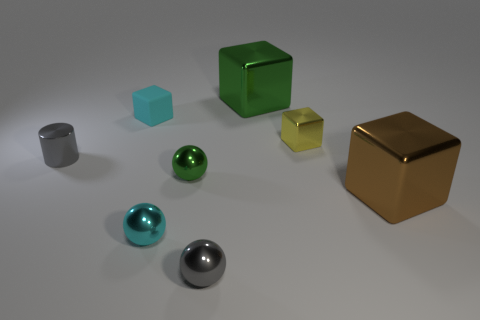There is a green thing in front of the gray metal cylinder; what material is it?
Offer a very short reply. Metal. The ball that is the same color as the small matte thing is what size?
Ensure brevity in your answer.  Small. What number of things are either big metallic things in front of the small gray cylinder or large blue metallic blocks?
Your answer should be very brief. 1. Are there the same number of yellow cubes on the left side of the small yellow metal thing and gray objects?
Make the answer very short. No. Is the size of the cylinder the same as the cyan block?
Provide a succinct answer. Yes. What is the color of the shiny thing that is the same size as the green metallic block?
Give a very brief answer. Brown. Is the size of the cyan cube the same as the ball that is behind the brown cube?
Keep it short and to the point. Yes. What number of matte blocks are the same color as the metal cylinder?
Offer a terse response. 0. What number of objects are either small cyan balls or tiny shiny balls that are in front of the tiny cyan metallic thing?
Give a very brief answer. 2. Does the yellow metallic cube behind the tiny green metal object have the same size as the gray metal thing that is left of the gray ball?
Your response must be concise. Yes. 